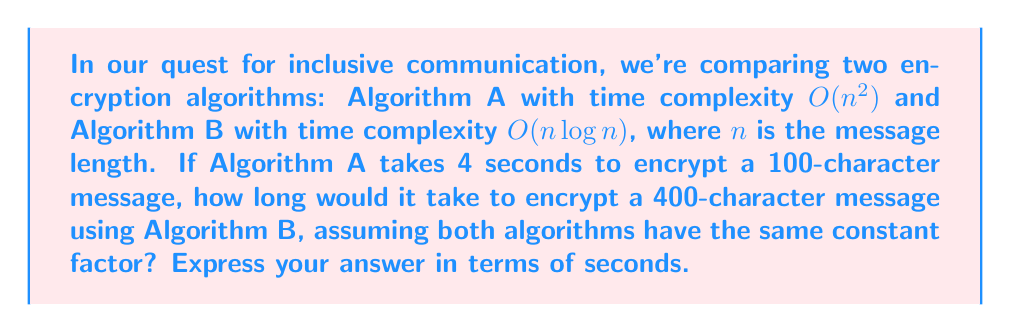Give your solution to this math problem. Let's approach this step-by-step:

1) First, we need to understand the relationship between the time complexities:
   Algorithm A: $O(n^2)$
   Algorithm B: $O(n \log n)$

2) We're given that Algorithm A takes 4 seconds for $n = 100$. Let's call the constant factor $k$:
   $k \cdot 100^2 = 4$
   $k = \frac{4}{10000} = 0.0004$

3) Now, we need to find the time for Algorithm B with $n = 400$:
   Time = $k \cdot 400 \log 400$

4) Let's calculate $\log 400$:
   $\log 400 = \log (20^2) = 2 \log 20 \approx 2 \cdot 2.9957 = 5.9914$

5) Now we can calculate the time:
   Time = $0.0004 \cdot 400 \cdot 5.9914 = 0.95862$ seconds

6) Rounding to two decimal places for practical purposes:
   Time ≈ 0.96 seconds
Answer: 0.96 seconds 